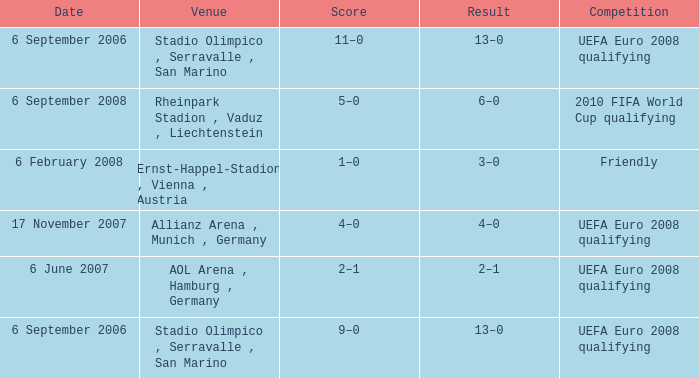Help me parse the entirety of this table. {'header': ['Date', 'Venue', 'Score', 'Result', 'Competition'], 'rows': [['6 September 2006', 'Stadio Olimpico , Serravalle , San Marino', '11–0', '13–0', 'UEFA Euro 2008 qualifying'], ['6 September 2008', 'Rheinpark Stadion , Vaduz , Liechtenstein', '5–0', '6–0', '2010 FIFA World Cup qualifying'], ['6 February 2008', 'Ernst-Happel-Stadion , Vienna , Austria', '1–0', '3–0', 'Friendly'], ['17 November 2007', 'Allianz Arena , Munich , Germany', '4–0', '4–0', 'UEFA Euro 2008 qualifying'], ['6 June 2007', 'AOL Arena , Hamburg , Germany', '2–1', '2–1', 'UEFA Euro 2008 qualifying'], ['6 September 2006', 'Stadio Olimpico , Serravalle , San Marino', '9–0', '13–0', 'UEFA Euro 2008 qualifying']]} On what Date did the friendly Competition take place? 6 February 2008. 